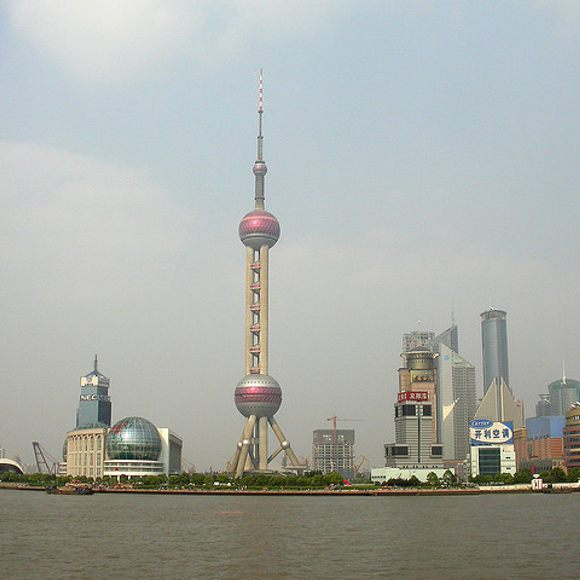What might be happening in this city right now? Considering this is an image of Shanghai, one of the world's most bustling metropolises, there are likely countless activities happening right now. In the central business district surrounding the Oriental Pearl Tower, business professionals could be attending important meetings in high-rise office buildings. Tourists might be visiting iconic attractions, sightseeing, and capturing photographs. The restaurants and cafes could be filled with people enjoying meals and socializing. On the river, you might find boats ferrying passengers or providing leisure cruises. The city’s rapid pace involves constant construction, trade, and cultural events, making it a vibrant and dynamic environment. Can you give me a story about one particular event in the city at this moment? Sure! Imagine a young entrepreneur named Lian who just moved to Shanghai. Today, she’s preparing for a significant moment in her career. Lian has secured a meeting with potential investors for her innovative tech startup, set in one of the prestigious high-rise buildings adjacent to the Oriental Pearl Tower. As she walks along the riverbank on her way to the building, she carries a sense of both excitement and nervousness. The city's skyline reflects off the water, adding to her sense of ambition and purpose. She steps into the glass elevator of the building, watching the panoramic view of the Oriental Pearl Tower and the cityscape spread out before her. Inside the meeting room, she confidently presents her ideas, the iconic tower visible through the large windows behind her, symbolizing the potential heights her career could reach. The investors are impressed by her presentation and decide to back her startup, marking the beginning of an exciting new chapter in her life. This story is just one of many that illustrates the ambitions and dreams being pursued in the vibrant city of Shanghai. 